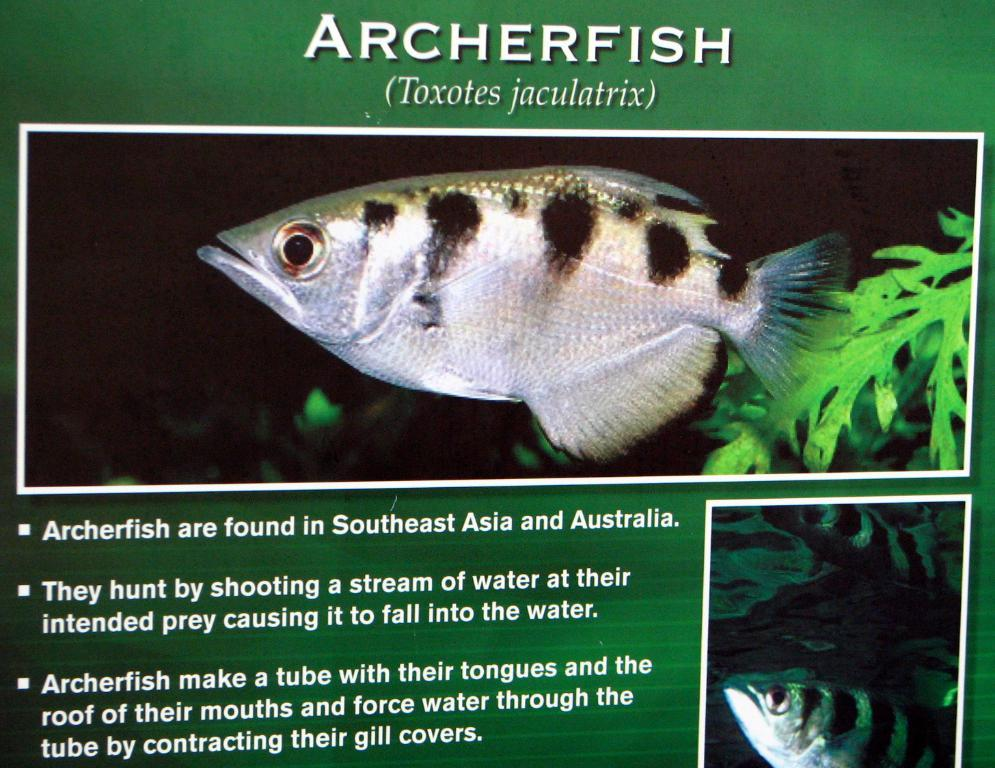What is the main object in the image? There is an information board in the image. What is depicted on the information board? There is a fish picture on the information board. Where is the peace symbol located in the image? There is no peace symbol present in the image. What type of stage is set up for the fish picture in the image? There is no stage present in the image; it only features an information board with a fish picture. 